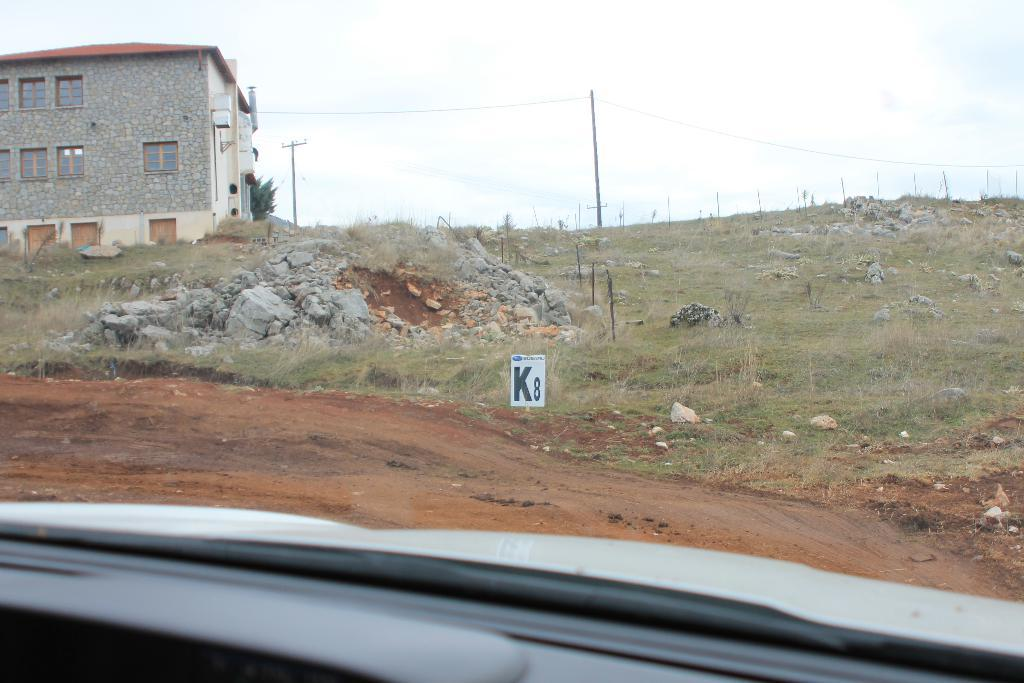What type of vegetation is present in the image? There is grass in the image. What type of structure can be seen in the image? There is a fence in the image. What is attached to the poles in the image? There are wires attached to the poles in the image. What object is on the ground in the image? There is a board on the ground in the image. What is located on the left side of the image? There is a building on the left side of the image. What part of the natural environment is visible in the image? The sky is visible in the image. How many oranges are hanging from the wires in the image? There are no oranges present in the image; it features poles with wires attached. What type of degree is required to enter the cave in the image? There is no cave present in the image, so the question of a required degree is not applicable. 